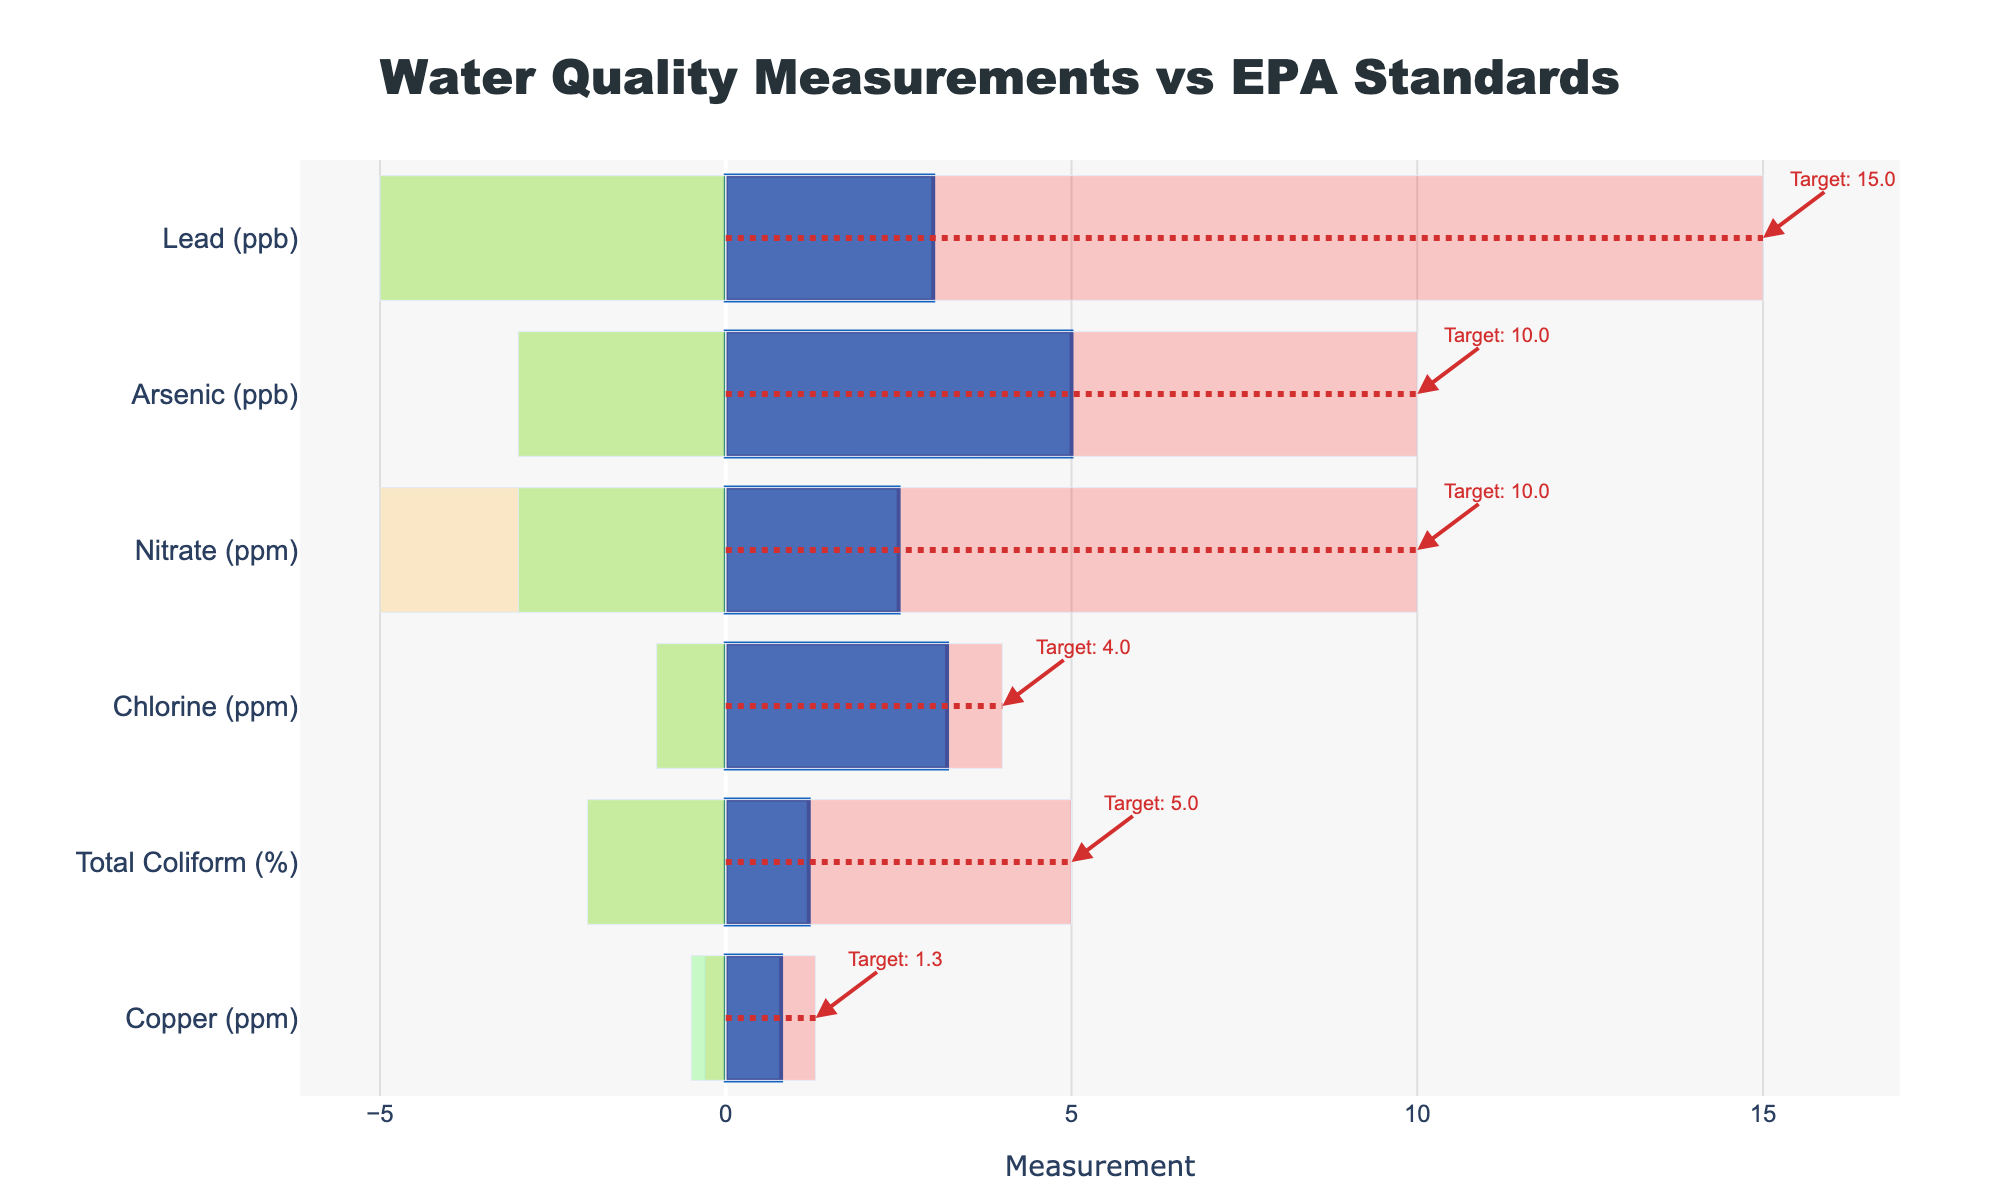What's the highest actual measurement recorded, and for which contaminant is it? By examining the bar lengths on the x-axis, the longest bar corresponds to Chlorine with an actual measurement of 3.2 ppm.
Answer: Chlorine (3.2 ppm) What is the target value for Lead? Inspect the dot-dashed target lines for each contaminant category; for Lead, the annotation near the end of the line indicates a target value of 15 ppb.
Answer: 15 ppb Which contaminant is closest to its target value? By comparing the length of each 'Actual' bar to its respective target line, Chlorine is closest to its target with an actual value of 3.2 ppm and a target value of 4 ppm.
Answer: Chlorine Which contaminants have actual measurements that fall into the 'Poor' category? Inspect the placement of the actual measurement bars relative to the 'Poor' range shaded in light red; Lead (3 ppb) and Copper (0.8 ppm) fall into the 'Poor' category.
Answer: Lead and Copper How many contaminants have their actual measurements lower than their target values? Count the contaminants where the 'Actual' bar is shorter than the dashed target line: Lead, Copper, Nitrate, Arsenic, Total Coliform, Chlorine (all 6 contaminants).
Answer: 6 Compare the actual measurements of Arsenic and Nitrate. Which one is higher? By comparing the bar lengths, Arsenic (5 ppb) is higher than Nitrate (2.5 ppm).
Answer: Arsenic What is the range defined as 'Satisfactory' for Copper? The 'Satisfactory' range is between the boundaries of 'Poor' and 'Good.' For Copper, this is 0.5 ppm (Good) and 1.3 ppm (Poor), making the satisfactory range 1.3 ppm - 0.5 ppm = 0.8 ppm.
Answer: 0.8 ppm Which contaminants have their actual measurements within the 'Good' category? Compare the actual measurement bars to the shaded areas for 'Good' category in green. The contaminants within 'Good' are Total Coliform, Chlorine, and Nitrate.
Answer: Total Coliform, Chlorine, Nitrate What's the difference between the actual and target values for Total Coliform? Subtract the actual value (1.2%) from the target value (5%): 5 - 1.2 = 3.8%.
Answer: 3.8% 